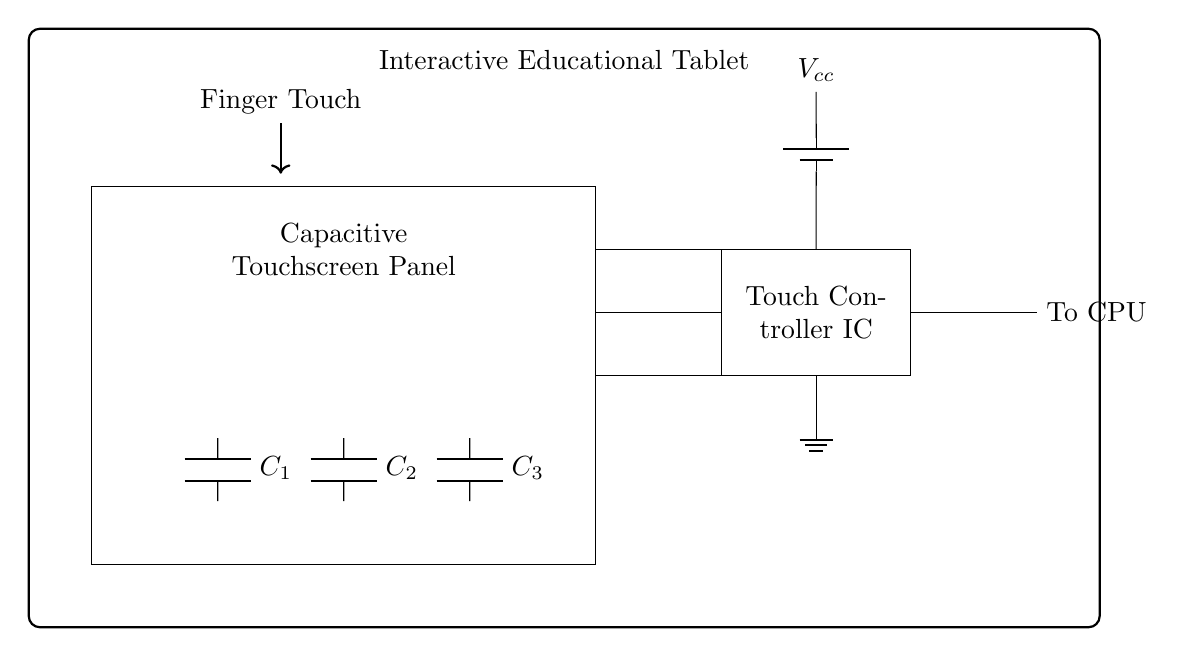What is the main component of the interactive educational tablet? The main component shown in the circuit diagram is the "Capacitive Touchscreen Panel," indicated by the rectangle labeled as such.
Answer: Capacitive Touchscreen Panel What does the touch controller IC connect to? The touch controller IC is connected to the CPU, as denoted by the line labeled "To CPU." This demonstrates the communication pathway from the touch controller to the processing unit.
Answer: To CPU What is the function of the capacitors present in the circuit? The capacitors (C1, C2, and C3) serve to filter and stabilize the signals from the touchscreen panel, allowing it to detect touches effectively. Capacitors in such applications often help with charge storage and signal integrity.
Answer: Filtering and stabilizing signals What is the voltage supplied to the touch controller IC? The schematic indicates a connection to a battery labeled with a voltage designation of "Vcc," which implies the voltage supplied to the IC is the same as the battery output.
Answer: Vcc What is the ground reference in the circuit? The ground reference in the circuit is indicated by the ground symbol connected to the touch controller IC. This establishes a common return path for current in the circuit, critical for proper operation.
Answer: Ground Explain why the finger touch is represented in the diagram. The finger touch is illustrated by an arrow, which shows interaction with the touchscreen panel. This visual element emphasizes the device's purpose of allowing user interaction through touch, highlighting the functionality of the capacitive technology in detecting finger placements.
Answer: User interaction How many capacitors are present in the circuit diagram? The circuit diagram shows three capacitors labeled as C1, C2, and C3. The count confirms the number of components responsible for helping to filter signals within the capacitive touchscreen circuitry.
Answer: Three capacitors 